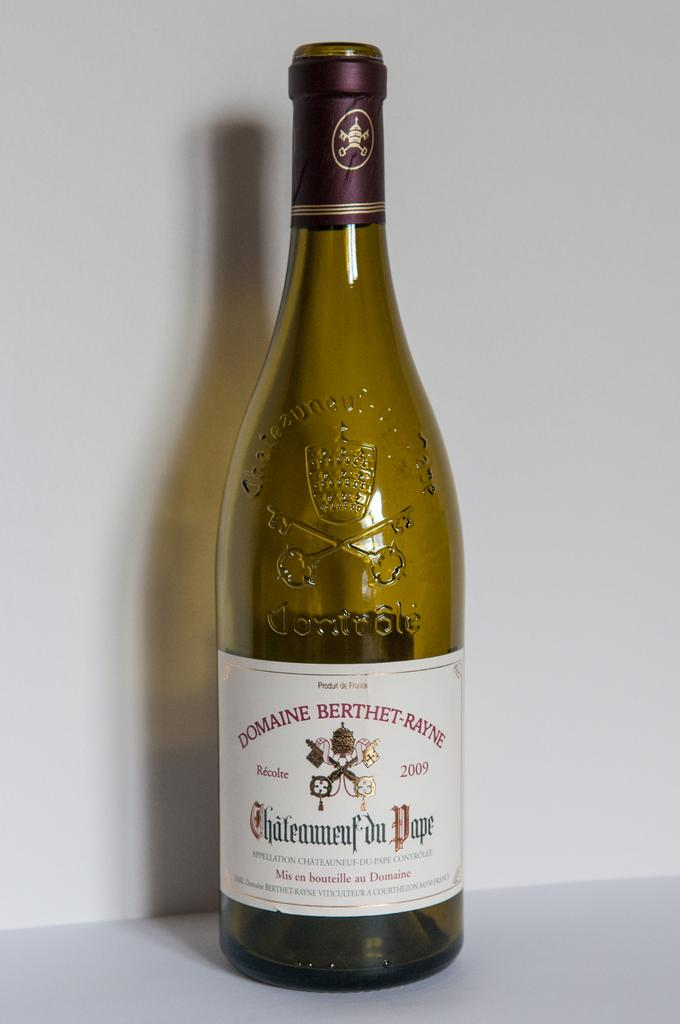<image>
Offer a succinct explanation of the picture presented. A empty bottle of Domaine Berthet-rayne wine stands alone. 